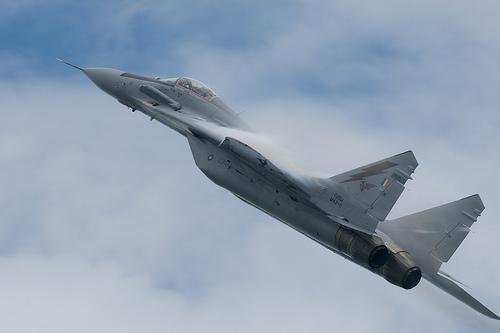Mention three identifiable features on the plane present in the image. A lighting bolt on the tail, glass over the cockpit, and writing to identify the plane. Can you provide a brief description of the underside of the fighter jet in the image? The underside of the fighter jet includes engines located on the back and a wing on the side. List the colors present in the sky and the appearance of clouds in the image. The sky is blue with white and wispy clouds against it. What is a distinguishable aspect of the nose of the fighter jet in the image? The nose of the fighter jet has a pointed shape. From the image descriptions, can you tell if the plane is ascending or descending in flight? The plane is ascending, as it is described to be going upward. What kind of jet is depicted in the image and what is it doing? A gray military jet is flying in a cloudy sky, going upward with a pointed nose. What is the primary object in the picture, and what environment is it in? The primary object is a gray military jet, and it is flying in a blue sky with white, wispy clouds. What is the current position of the fighter jet in the image concerning the sky and clouds? The fighter jet is climbing through the air in a blue sky with white clouds. Can you describe the design or emblem painted on the plane in the image? There is a lightning bolt painted on the plane's tail, and an emblem on its side. Which part of the fighter jet has a window, and how does it look? The cockpit of the fighter jet has a window with glass covering it. 